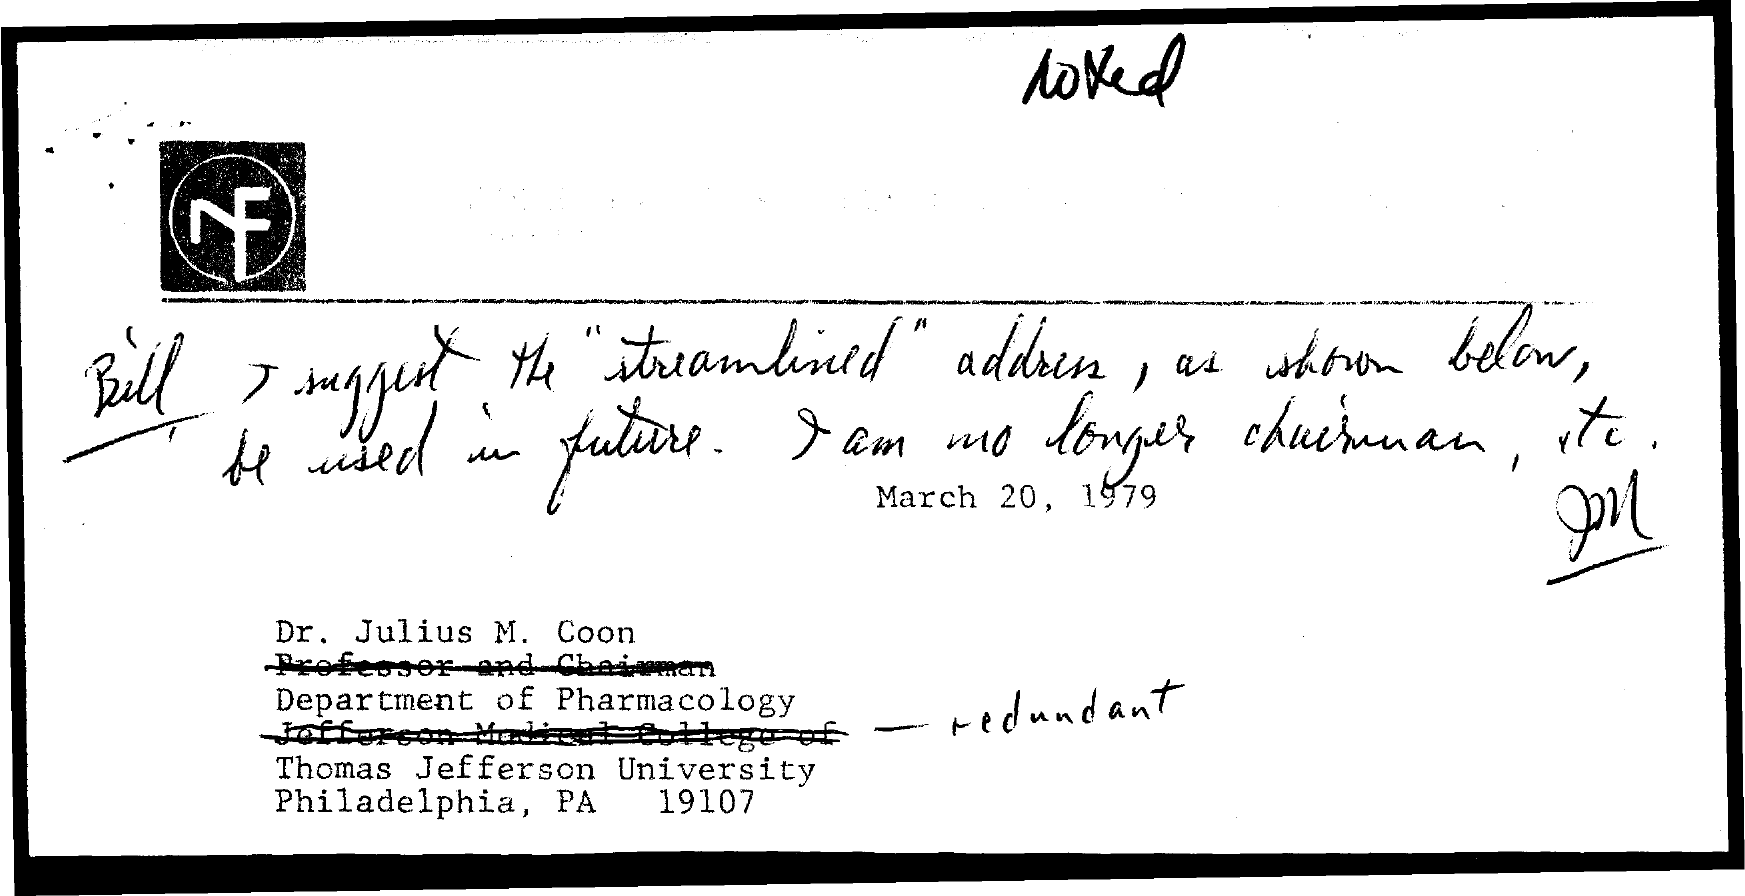What is the date mentioned in the document?
Your answer should be compact. March 20, 1979. Dr.Julius M. Coon belongs to which university?
Give a very brief answer. Thomas Jefferson University. Dr.Julius M. Coon belongs to which department?
Ensure brevity in your answer.  Department of pharmacology. 